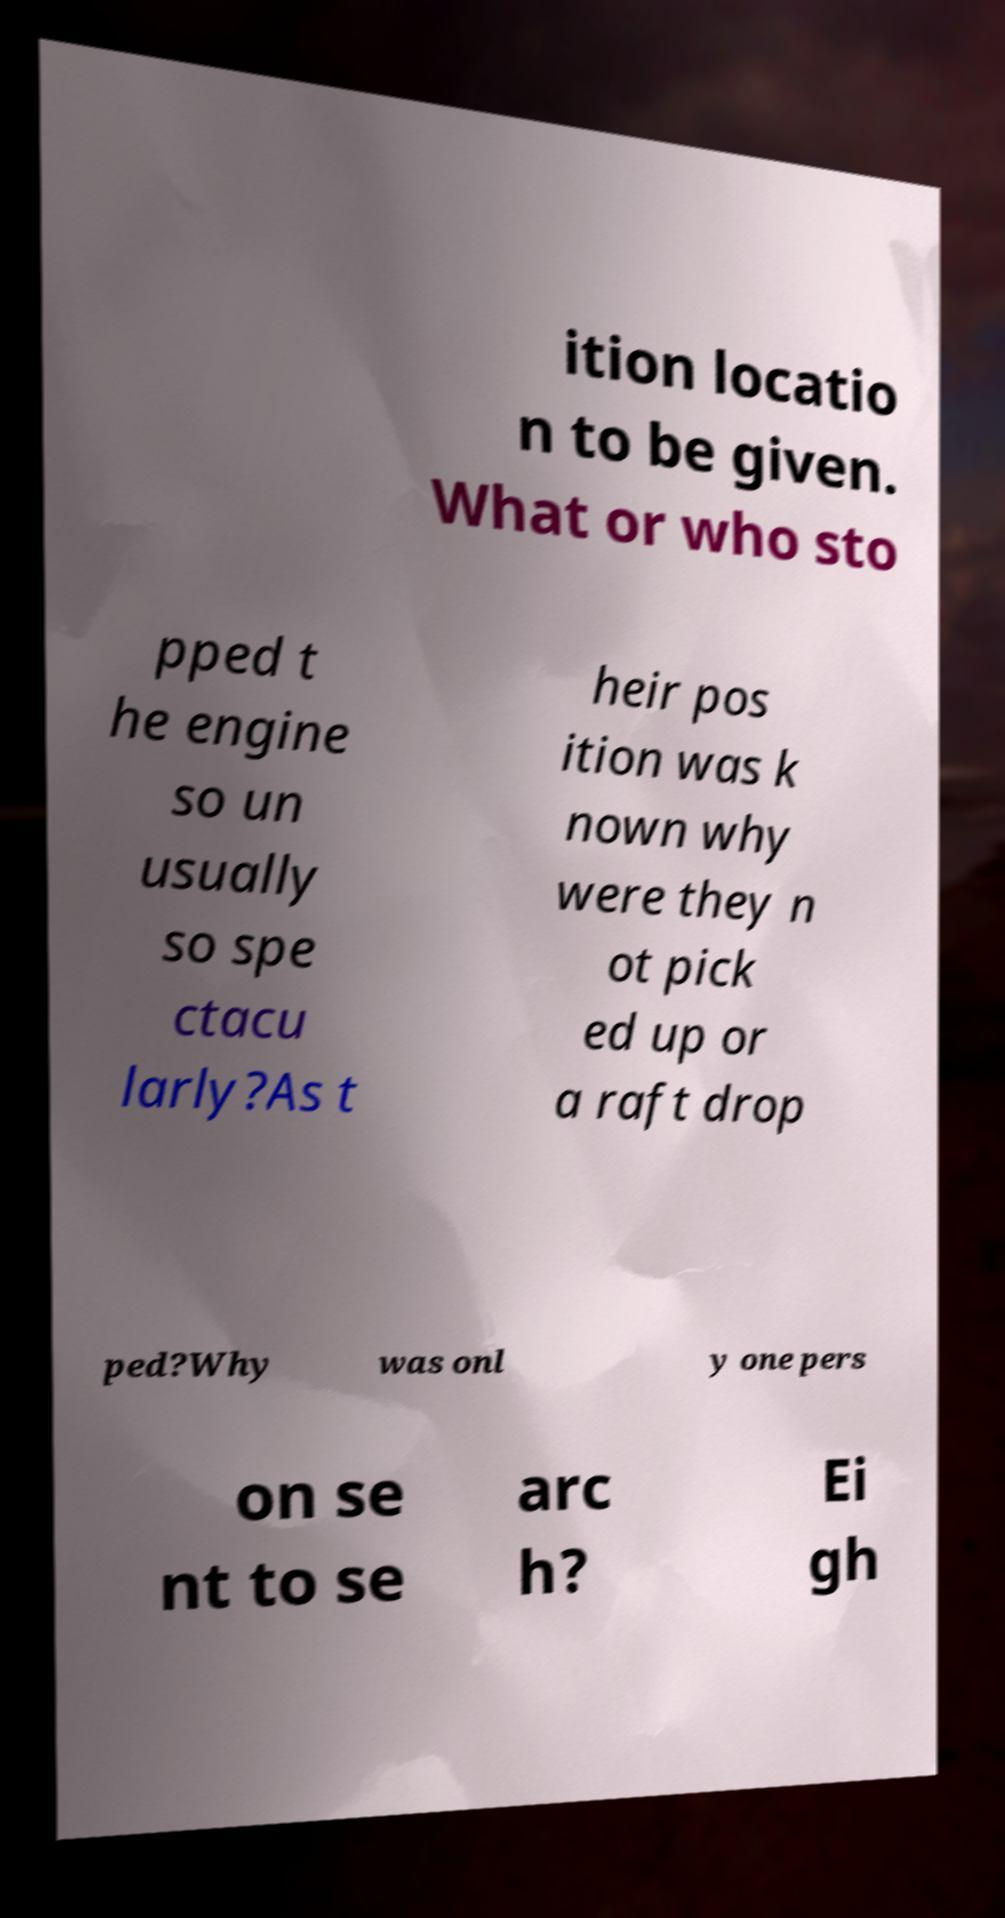Can you read and provide the text displayed in the image?This photo seems to have some interesting text. Can you extract and type it out for me? ition locatio n to be given. What or who sto pped t he engine so un usually so spe ctacu larly?As t heir pos ition was k nown why were they n ot pick ed up or a raft drop ped?Why was onl y one pers on se nt to se arc h? Ei gh 